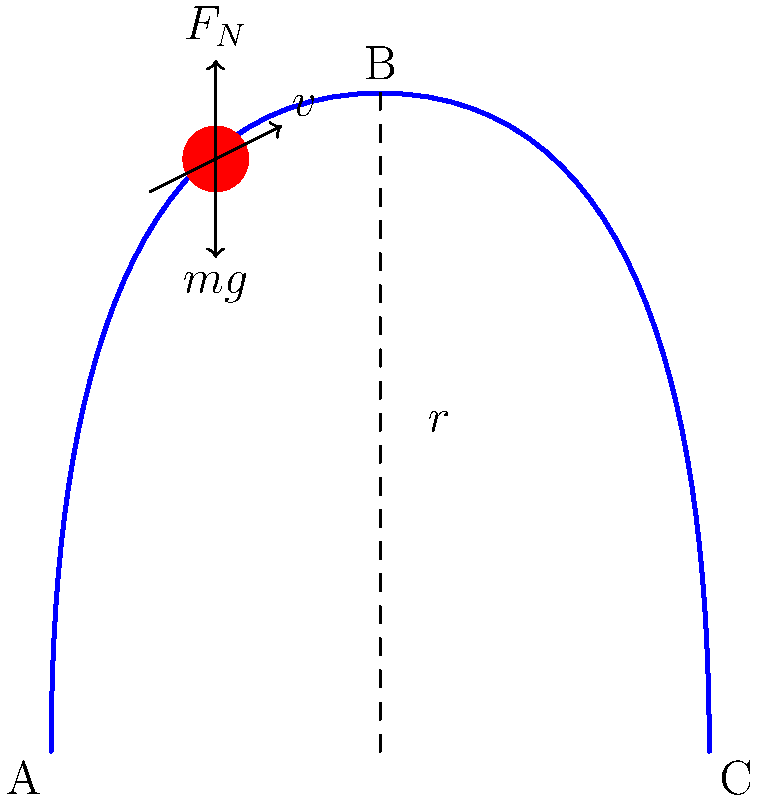A roller coaster car of mass $m$ needs to complete a vertical circular loop of radius $r$ at Disneyland. At the top of the loop (point B), what is the minimum speed $v$ required for the car to complete the loop without falling, and what is the normal force $F_N$ exerted by the track on the car at this point? To solve this problem, we'll use the concepts of circular motion and Newton's laws of motion.

Step 1: Minimum speed at the top of the loop
At the top of the loop, two forces act on the car: gravity ($mg$) downward and the normal force ($F_N$) inward. For the car to stay on the track, the centripetal force must be at least equal to the gravitational force.

$$ F_c = \frac{mv^2}{r} \geq mg $$

The minimum speed occurs when these forces are equal:

$$ \frac{mv^2}{r} = mg $$

Solving for $v$:

$$ v = \sqrt{gr} $$

Step 2: Normal force at the top of the loop
At the minimum speed, the normal force at the top of the loop is zero because the centripetal force is entirely provided by gravity. However, to ensure the car stays on the track, a small normal force is usually required. We can calculate this using Newton's second law:

$$ F_N + mg = \frac{mv^2}{r} $$

Substituting $v = \sqrt{gr}$:

$$ F_N + mg = \frac{m(gr)}{r} = mg $$

$$ F_N = mg - mg = 0 $$

Therefore, at the minimum speed to complete the loop, the normal force at the top is theoretically zero.
Answer: Minimum speed: $v = \sqrt{gr}$, Normal force: $F_N = 0$ 